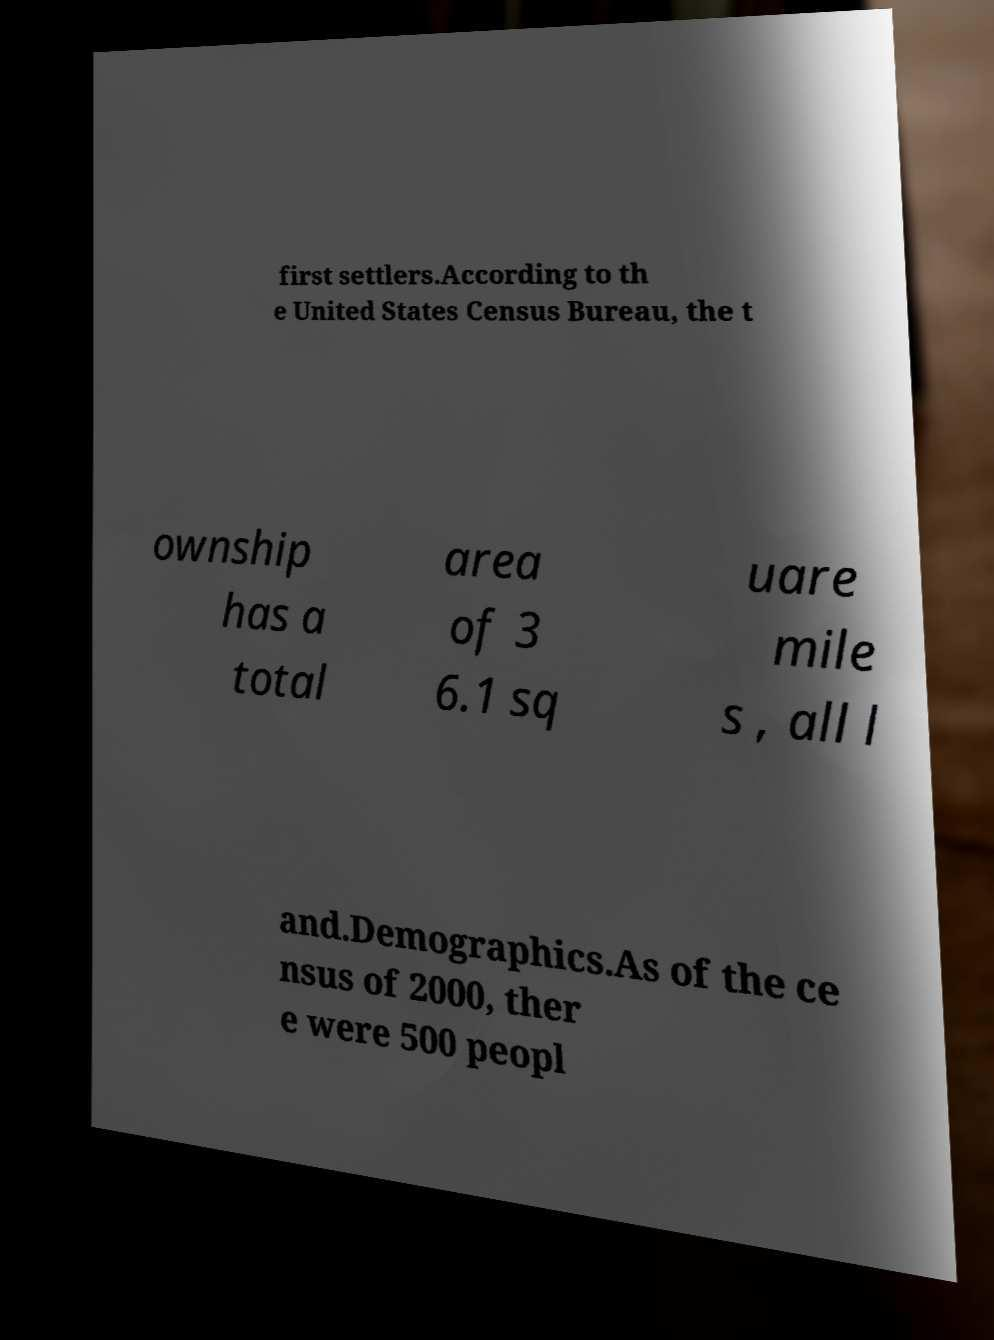Could you assist in decoding the text presented in this image and type it out clearly? first settlers.According to th e United States Census Bureau, the t ownship has a total area of 3 6.1 sq uare mile s , all l and.Demographics.As of the ce nsus of 2000, ther e were 500 peopl 